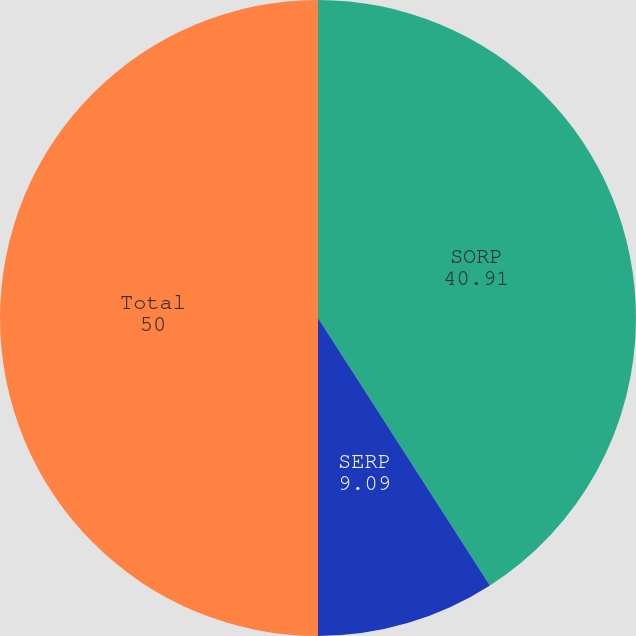<chart> <loc_0><loc_0><loc_500><loc_500><pie_chart><fcel>SORP<fcel>SERP<fcel>Total<nl><fcel>40.91%<fcel>9.09%<fcel>50.0%<nl></chart> 